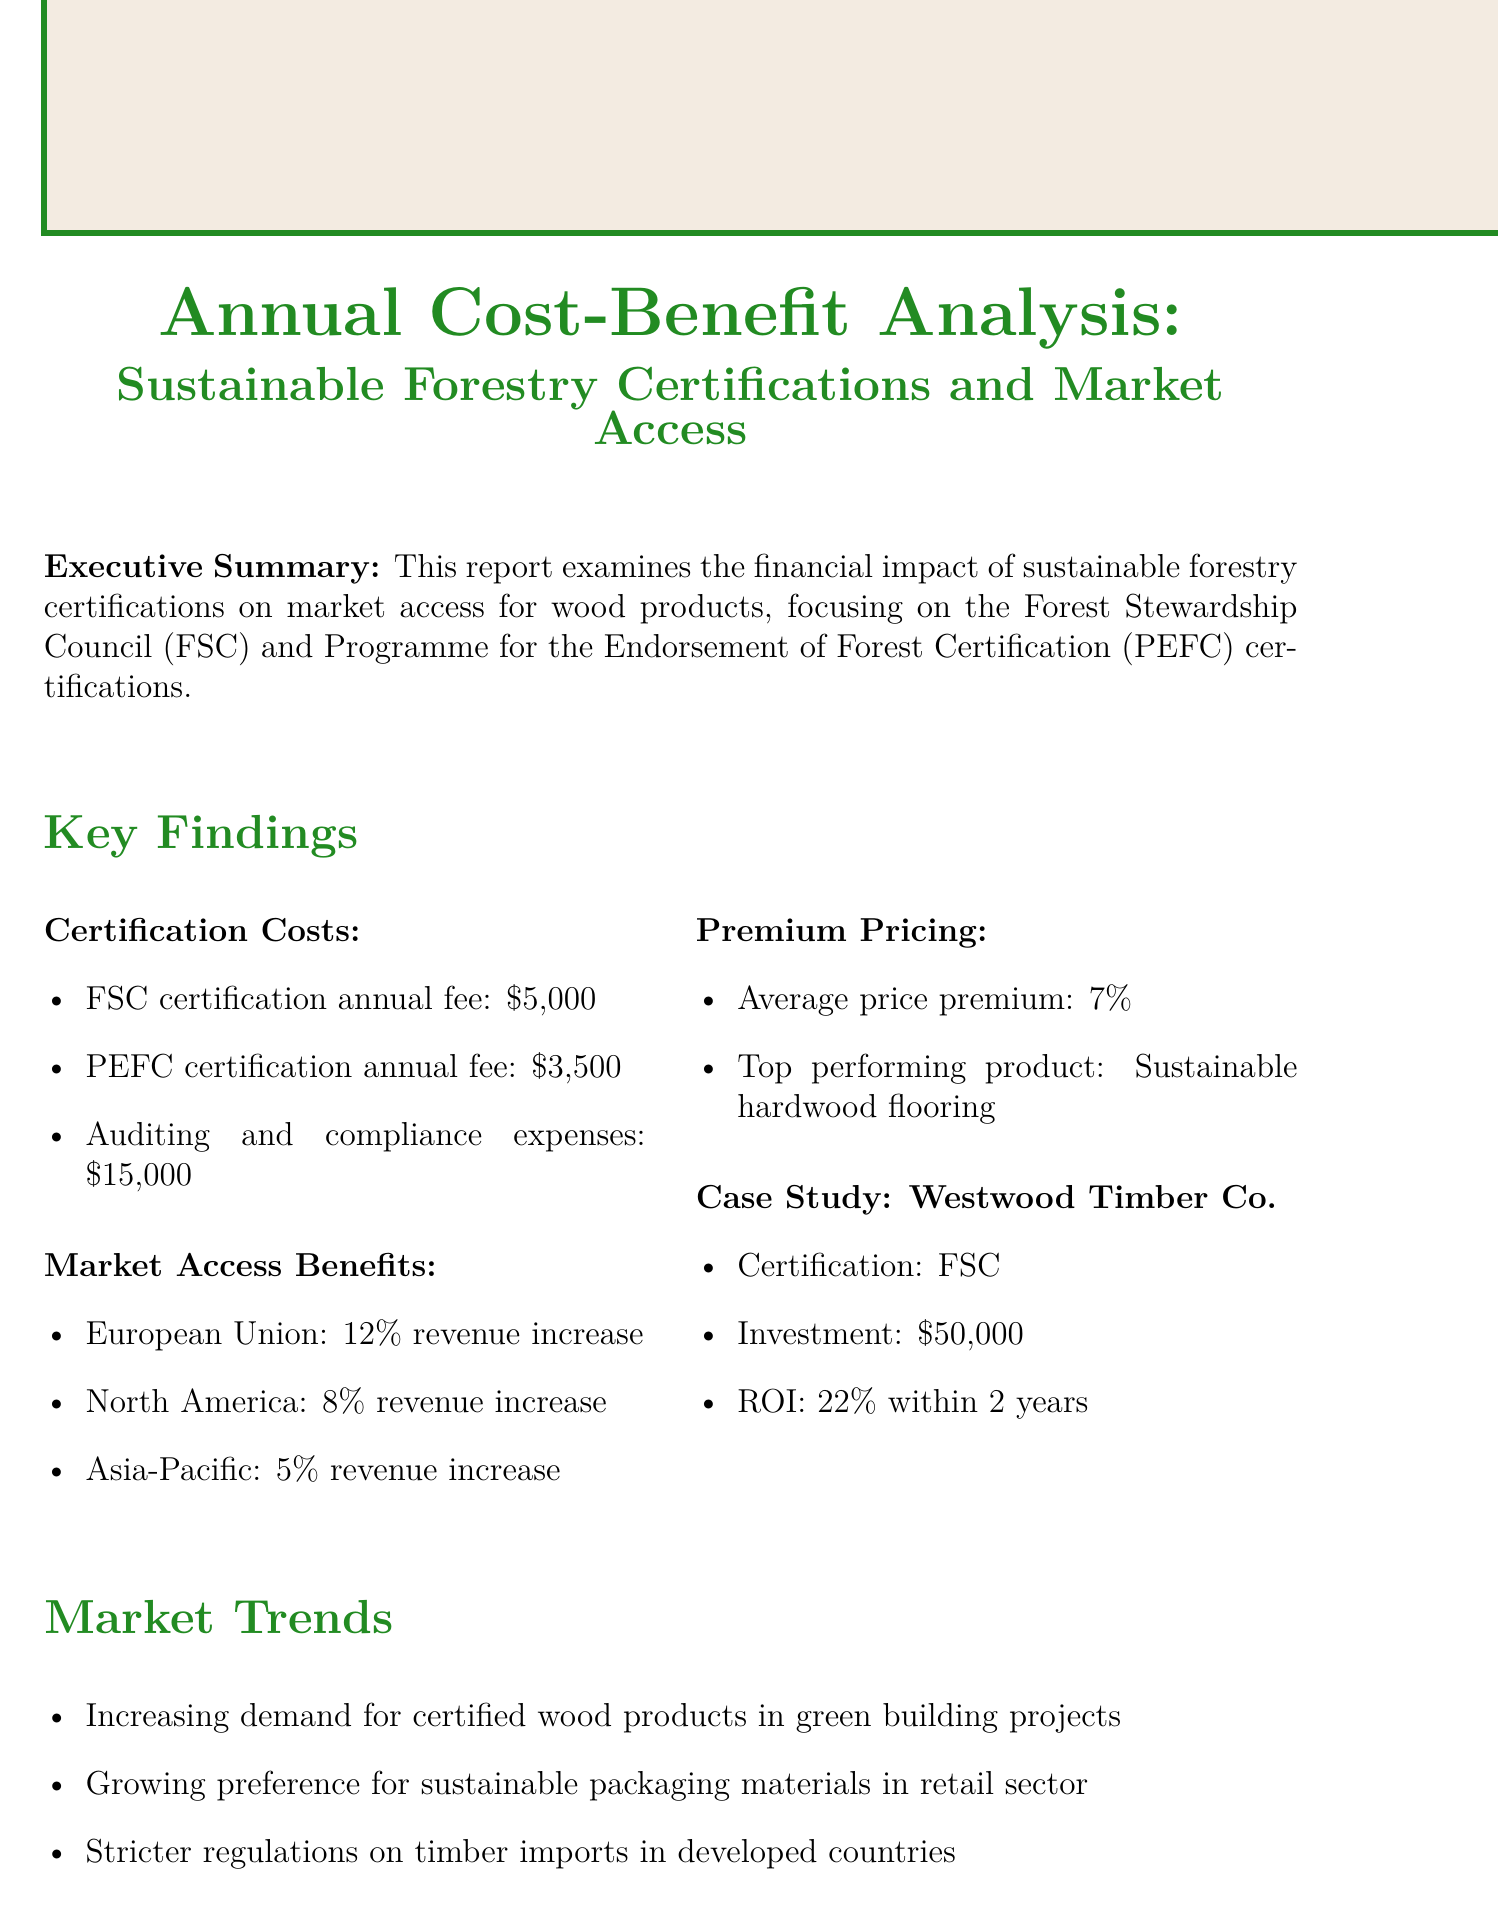What is the FSC certification annual fee? The report states the FSC certification annual fee explicitly.
Answer: $5,000 What is the ROI for Westwood Timber Co.? The report provides the ROI for Westwood Timber Co. based on their investment in FSC certification.
Answer: 22% within 2 years What is the average price premium for certified wood products? The report mentions the average price premium associated with certified wood products.
Answer: 7% Which market has the highest revenue increase? The report lists the revenue increases for different markets, indicating which has the highest percentage.
Answer: European Union What are two market trends identified in the report? The document outlines various market trends affecting the wood product industry.
Answer: Increasing demand for certified wood products in green building projects, Growing preference for sustainable packaging materials in retail sector How much is the auditing and compliance expense? The report details the expenses associated with certification, including auditing and compliance.
Answer: $15,000 What certification does Westwood Timber Co. have? The case study specifies the type of certification held by Westwood Timber Co.
Answer: FSC What is the investment amount for Westwood Timber Co.? The report states the amount invested by Westwood Timber Co. for certification.
Answer: $50,000 